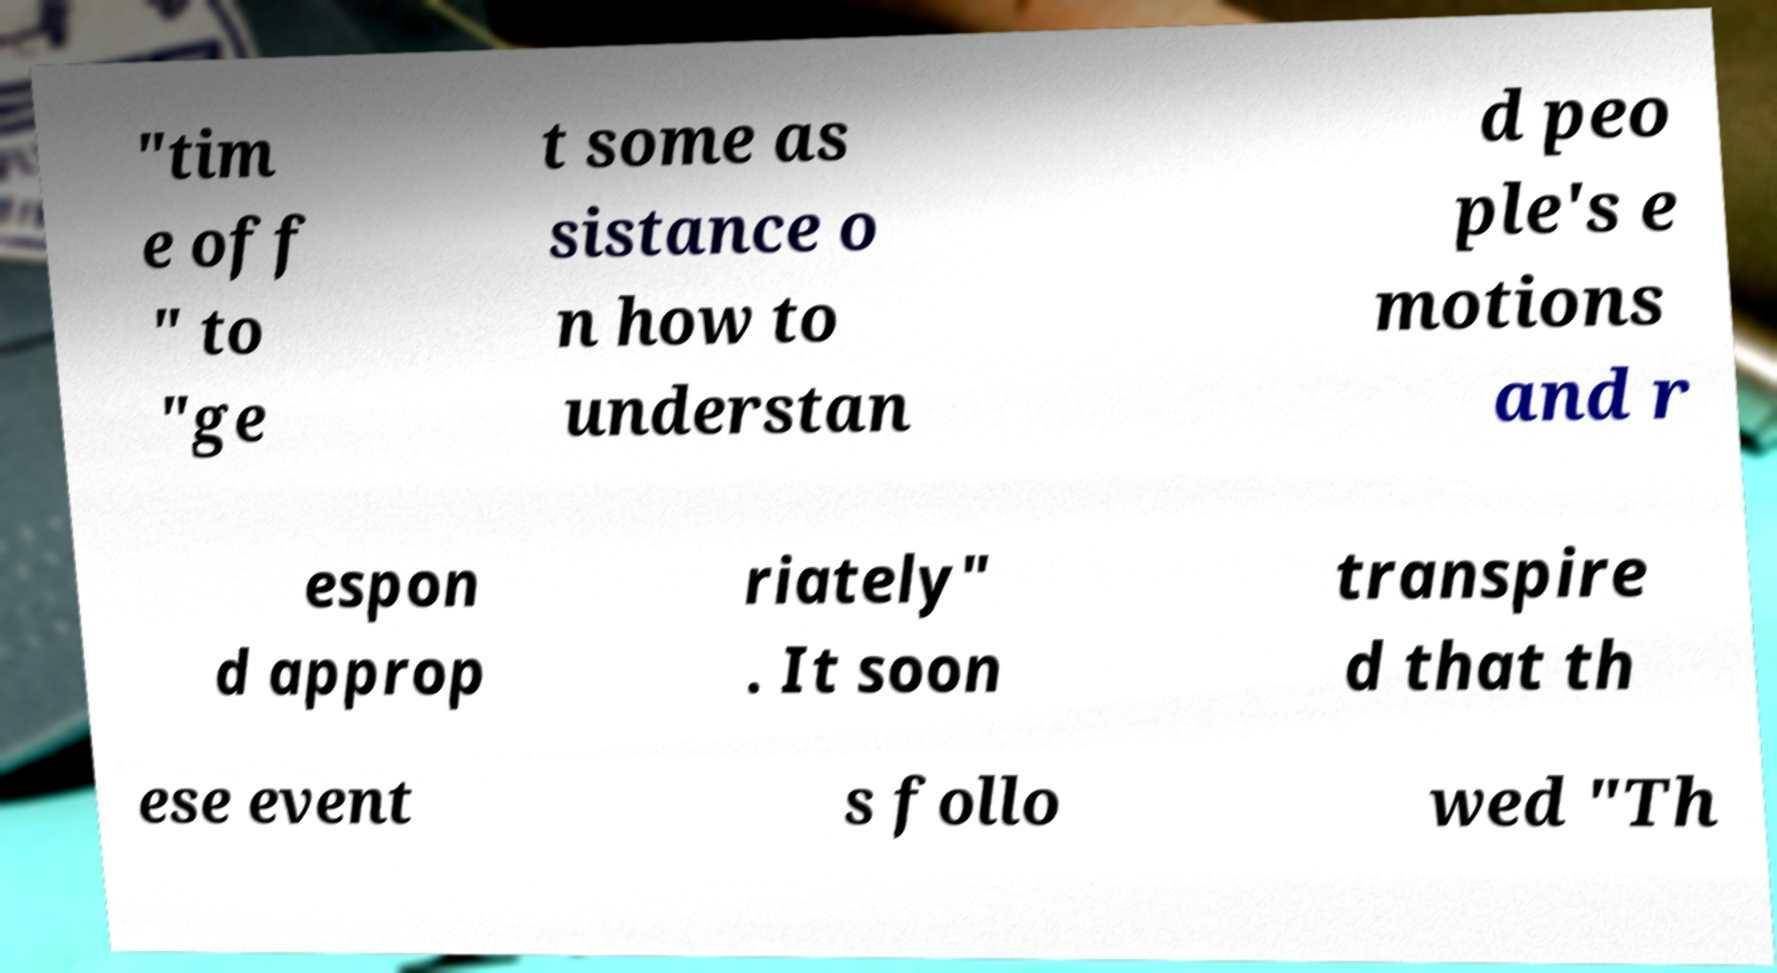For documentation purposes, I need the text within this image transcribed. Could you provide that? "tim e off " to "ge t some as sistance o n how to understan d peo ple's e motions and r espon d approp riately" . It soon transpire d that th ese event s follo wed "Th 